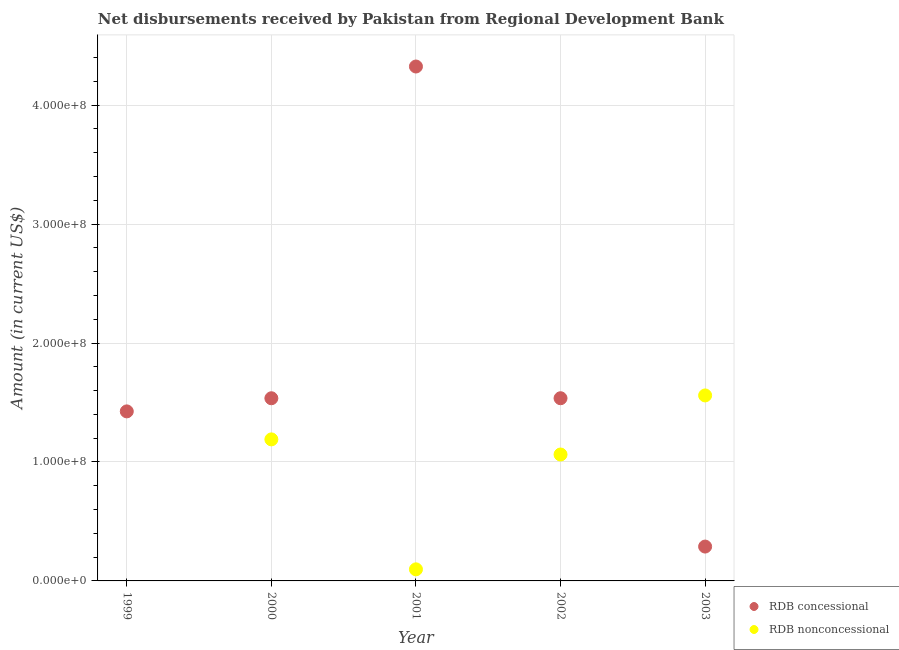Is the number of dotlines equal to the number of legend labels?
Give a very brief answer. No. What is the net non concessional disbursements from rdb in 2001?
Offer a very short reply. 9.74e+06. Across all years, what is the maximum net non concessional disbursements from rdb?
Ensure brevity in your answer.  1.56e+08. Across all years, what is the minimum net concessional disbursements from rdb?
Ensure brevity in your answer.  2.89e+07. In which year was the net concessional disbursements from rdb maximum?
Offer a very short reply. 2001. What is the total net concessional disbursements from rdb in the graph?
Ensure brevity in your answer.  9.11e+08. What is the difference between the net concessional disbursements from rdb in 1999 and that in 2002?
Give a very brief answer. -1.11e+07. What is the difference between the net concessional disbursements from rdb in 2003 and the net non concessional disbursements from rdb in 1999?
Your answer should be compact. 2.89e+07. What is the average net non concessional disbursements from rdb per year?
Make the answer very short. 7.82e+07. In the year 2000, what is the difference between the net concessional disbursements from rdb and net non concessional disbursements from rdb?
Give a very brief answer. 3.46e+07. What is the ratio of the net concessional disbursements from rdb in 1999 to that in 2000?
Offer a terse response. 0.93. Is the net non concessional disbursements from rdb in 2002 less than that in 2003?
Offer a very short reply. Yes. What is the difference between the highest and the second highest net non concessional disbursements from rdb?
Your response must be concise. 3.70e+07. What is the difference between the highest and the lowest net concessional disbursements from rdb?
Your answer should be compact. 4.04e+08. In how many years, is the net non concessional disbursements from rdb greater than the average net non concessional disbursements from rdb taken over all years?
Provide a succinct answer. 3. Is the sum of the net concessional disbursements from rdb in 1999 and 2003 greater than the maximum net non concessional disbursements from rdb across all years?
Offer a terse response. Yes. How many dotlines are there?
Give a very brief answer. 2. What is the difference between two consecutive major ticks on the Y-axis?
Provide a short and direct response. 1.00e+08. Are the values on the major ticks of Y-axis written in scientific E-notation?
Ensure brevity in your answer.  Yes. Does the graph contain grids?
Make the answer very short. Yes. How many legend labels are there?
Provide a succinct answer. 2. How are the legend labels stacked?
Keep it short and to the point. Vertical. What is the title of the graph?
Keep it short and to the point. Net disbursements received by Pakistan from Regional Development Bank. Does "International Visitors" appear as one of the legend labels in the graph?
Keep it short and to the point. No. What is the label or title of the Y-axis?
Make the answer very short. Amount (in current US$). What is the Amount (in current US$) of RDB concessional in 1999?
Your answer should be very brief. 1.43e+08. What is the Amount (in current US$) in RDB nonconcessional in 1999?
Your answer should be compact. 0. What is the Amount (in current US$) of RDB concessional in 2000?
Offer a very short reply. 1.54e+08. What is the Amount (in current US$) in RDB nonconcessional in 2000?
Provide a succinct answer. 1.19e+08. What is the Amount (in current US$) in RDB concessional in 2001?
Your answer should be compact. 4.32e+08. What is the Amount (in current US$) in RDB nonconcessional in 2001?
Your answer should be compact. 9.74e+06. What is the Amount (in current US$) of RDB concessional in 2002?
Offer a terse response. 1.54e+08. What is the Amount (in current US$) in RDB nonconcessional in 2002?
Provide a succinct answer. 1.06e+08. What is the Amount (in current US$) of RDB concessional in 2003?
Keep it short and to the point. 2.89e+07. What is the Amount (in current US$) of RDB nonconcessional in 2003?
Provide a short and direct response. 1.56e+08. Across all years, what is the maximum Amount (in current US$) in RDB concessional?
Provide a short and direct response. 4.32e+08. Across all years, what is the maximum Amount (in current US$) of RDB nonconcessional?
Make the answer very short. 1.56e+08. Across all years, what is the minimum Amount (in current US$) in RDB concessional?
Your response must be concise. 2.89e+07. What is the total Amount (in current US$) in RDB concessional in the graph?
Provide a short and direct response. 9.11e+08. What is the total Amount (in current US$) in RDB nonconcessional in the graph?
Offer a terse response. 3.91e+08. What is the difference between the Amount (in current US$) in RDB concessional in 1999 and that in 2000?
Keep it short and to the point. -1.10e+07. What is the difference between the Amount (in current US$) in RDB concessional in 1999 and that in 2001?
Your answer should be very brief. -2.90e+08. What is the difference between the Amount (in current US$) of RDB concessional in 1999 and that in 2002?
Your answer should be compact. -1.11e+07. What is the difference between the Amount (in current US$) of RDB concessional in 1999 and that in 2003?
Make the answer very short. 1.14e+08. What is the difference between the Amount (in current US$) of RDB concessional in 2000 and that in 2001?
Provide a succinct answer. -2.79e+08. What is the difference between the Amount (in current US$) of RDB nonconcessional in 2000 and that in 2001?
Provide a short and direct response. 1.09e+08. What is the difference between the Amount (in current US$) in RDB concessional in 2000 and that in 2002?
Provide a short and direct response. -1.80e+04. What is the difference between the Amount (in current US$) in RDB nonconcessional in 2000 and that in 2002?
Your response must be concise. 1.27e+07. What is the difference between the Amount (in current US$) of RDB concessional in 2000 and that in 2003?
Provide a succinct answer. 1.25e+08. What is the difference between the Amount (in current US$) in RDB nonconcessional in 2000 and that in 2003?
Your answer should be compact. -3.70e+07. What is the difference between the Amount (in current US$) of RDB concessional in 2001 and that in 2002?
Offer a terse response. 2.79e+08. What is the difference between the Amount (in current US$) in RDB nonconcessional in 2001 and that in 2002?
Your answer should be very brief. -9.65e+07. What is the difference between the Amount (in current US$) in RDB concessional in 2001 and that in 2003?
Make the answer very short. 4.04e+08. What is the difference between the Amount (in current US$) in RDB nonconcessional in 2001 and that in 2003?
Your answer should be very brief. -1.46e+08. What is the difference between the Amount (in current US$) of RDB concessional in 2002 and that in 2003?
Your answer should be very brief. 1.25e+08. What is the difference between the Amount (in current US$) in RDB nonconcessional in 2002 and that in 2003?
Make the answer very short. -4.97e+07. What is the difference between the Amount (in current US$) of RDB concessional in 1999 and the Amount (in current US$) of RDB nonconcessional in 2000?
Your answer should be very brief. 2.35e+07. What is the difference between the Amount (in current US$) in RDB concessional in 1999 and the Amount (in current US$) in RDB nonconcessional in 2001?
Provide a short and direct response. 1.33e+08. What is the difference between the Amount (in current US$) in RDB concessional in 1999 and the Amount (in current US$) in RDB nonconcessional in 2002?
Your answer should be very brief. 3.62e+07. What is the difference between the Amount (in current US$) of RDB concessional in 1999 and the Amount (in current US$) of RDB nonconcessional in 2003?
Your answer should be very brief. -1.34e+07. What is the difference between the Amount (in current US$) of RDB concessional in 2000 and the Amount (in current US$) of RDB nonconcessional in 2001?
Your answer should be compact. 1.44e+08. What is the difference between the Amount (in current US$) of RDB concessional in 2000 and the Amount (in current US$) of RDB nonconcessional in 2002?
Your answer should be compact. 4.73e+07. What is the difference between the Amount (in current US$) in RDB concessional in 2000 and the Amount (in current US$) in RDB nonconcessional in 2003?
Provide a short and direct response. -2.37e+06. What is the difference between the Amount (in current US$) in RDB concessional in 2001 and the Amount (in current US$) in RDB nonconcessional in 2002?
Provide a short and direct response. 3.26e+08. What is the difference between the Amount (in current US$) in RDB concessional in 2001 and the Amount (in current US$) in RDB nonconcessional in 2003?
Keep it short and to the point. 2.77e+08. What is the difference between the Amount (in current US$) in RDB concessional in 2002 and the Amount (in current US$) in RDB nonconcessional in 2003?
Provide a short and direct response. -2.36e+06. What is the average Amount (in current US$) of RDB concessional per year?
Your answer should be very brief. 1.82e+08. What is the average Amount (in current US$) in RDB nonconcessional per year?
Offer a terse response. 7.82e+07. In the year 2000, what is the difference between the Amount (in current US$) of RDB concessional and Amount (in current US$) of RDB nonconcessional?
Offer a terse response. 3.46e+07. In the year 2001, what is the difference between the Amount (in current US$) of RDB concessional and Amount (in current US$) of RDB nonconcessional?
Your response must be concise. 4.23e+08. In the year 2002, what is the difference between the Amount (in current US$) in RDB concessional and Amount (in current US$) in RDB nonconcessional?
Your answer should be compact. 4.73e+07. In the year 2003, what is the difference between the Amount (in current US$) in RDB concessional and Amount (in current US$) in RDB nonconcessional?
Offer a terse response. -1.27e+08. What is the ratio of the Amount (in current US$) of RDB concessional in 1999 to that in 2000?
Provide a short and direct response. 0.93. What is the ratio of the Amount (in current US$) of RDB concessional in 1999 to that in 2001?
Your answer should be very brief. 0.33. What is the ratio of the Amount (in current US$) in RDB concessional in 1999 to that in 2002?
Give a very brief answer. 0.93. What is the ratio of the Amount (in current US$) in RDB concessional in 1999 to that in 2003?
Provide a short and direct response. 4.93. What is the ratio of the Amount (in current US$) of RDB concessional in 2000 to that in 2001?
Provide a succinct answer. 0.36. What is the ratio of the Amount (in current US$) of RDB nonconcessional in 2000 to that in 2001?
Provide a succinct answer. 12.22. What is the ratio of the Amount (in current US$) of RDB nonconcessional in 2000 to that in 2002?
Give a very brief answer. 1.12. What is the ratio of the Amount (in current US$) in RDB concessional in 2000 to that in 2003?
Make the answer very short. 5.32. What is the ratio of the Amount (in current US$) in RDB nonconcessional in 2000 to that in 2003?
Make the answer very short. 0.76. What is the ratio of the Amount (in current US$) of RDB concessional in 2001 to that in 2002?
Your answer should be very brief. 2.82. What is the ratio of the Amount (in current US$) of RDB nonconcessional in 2001 to that in 2002?
Offer a very short reply. 0.09. What is the ratio of the Amount (in current US$) in RDB concessional in 2001 to that in 2003?
Make the answer very short. 14.97. What is the ratio of the Amount (in current US$) of RDB nonconcessional in 2001 to that in 2003?
Your answer should be very brief. 0.06. What is the ratio of the Amount (in current US$) in RDB concessional in 2002 to that in 2003?
Keep it short and to the point. 5.32. What is the ratio of the Amount (in current US$) in RDB nonconcessional in 2002 to that in 2003?
Make the answer very short. 0.68. What is the difference between the highest and the second highest Amount (in current US$) of RDB concessional?
Your response must be concise. 2.79e+08. What is the difference between the highest and the second highest Amount (in current US$) of RDB nonconcessional?
Your response must be concise. 3.70e+07. What is the difference between the highest and the lowest Amount (in current US$) of RDB concessional?
Offer a very short reply. 4.04e+08. What is the difference between the highest and the lowest Amount (in current US$) of RDB nonconcessional?
Your answer should be very brief. 1.56e+08. 